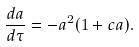Convert formula to latex. <formula><loc_0><loc_0><loc_500><loc_500>\frac { d a } { d \tau } = - a ^ { 2 } ( 1 + c a ) .</formula> 